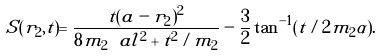Convert formula to latex. <formula><loc_0><loc_0><loc_500><loc_500>S ( { r } _ { 2 } , t ) = \frac { t ( { a } - { r } _ { 2 } ) ^ { 2 } } { 8 m _ { 2 } \ a l ^ { 2 } + t ^ { 2 } / m _ { 2 } } - \frac { 3 } { 2 } \tan ^ { - 1 } ( t / 2 m _ { 2 } \alpha ) .</formula> 